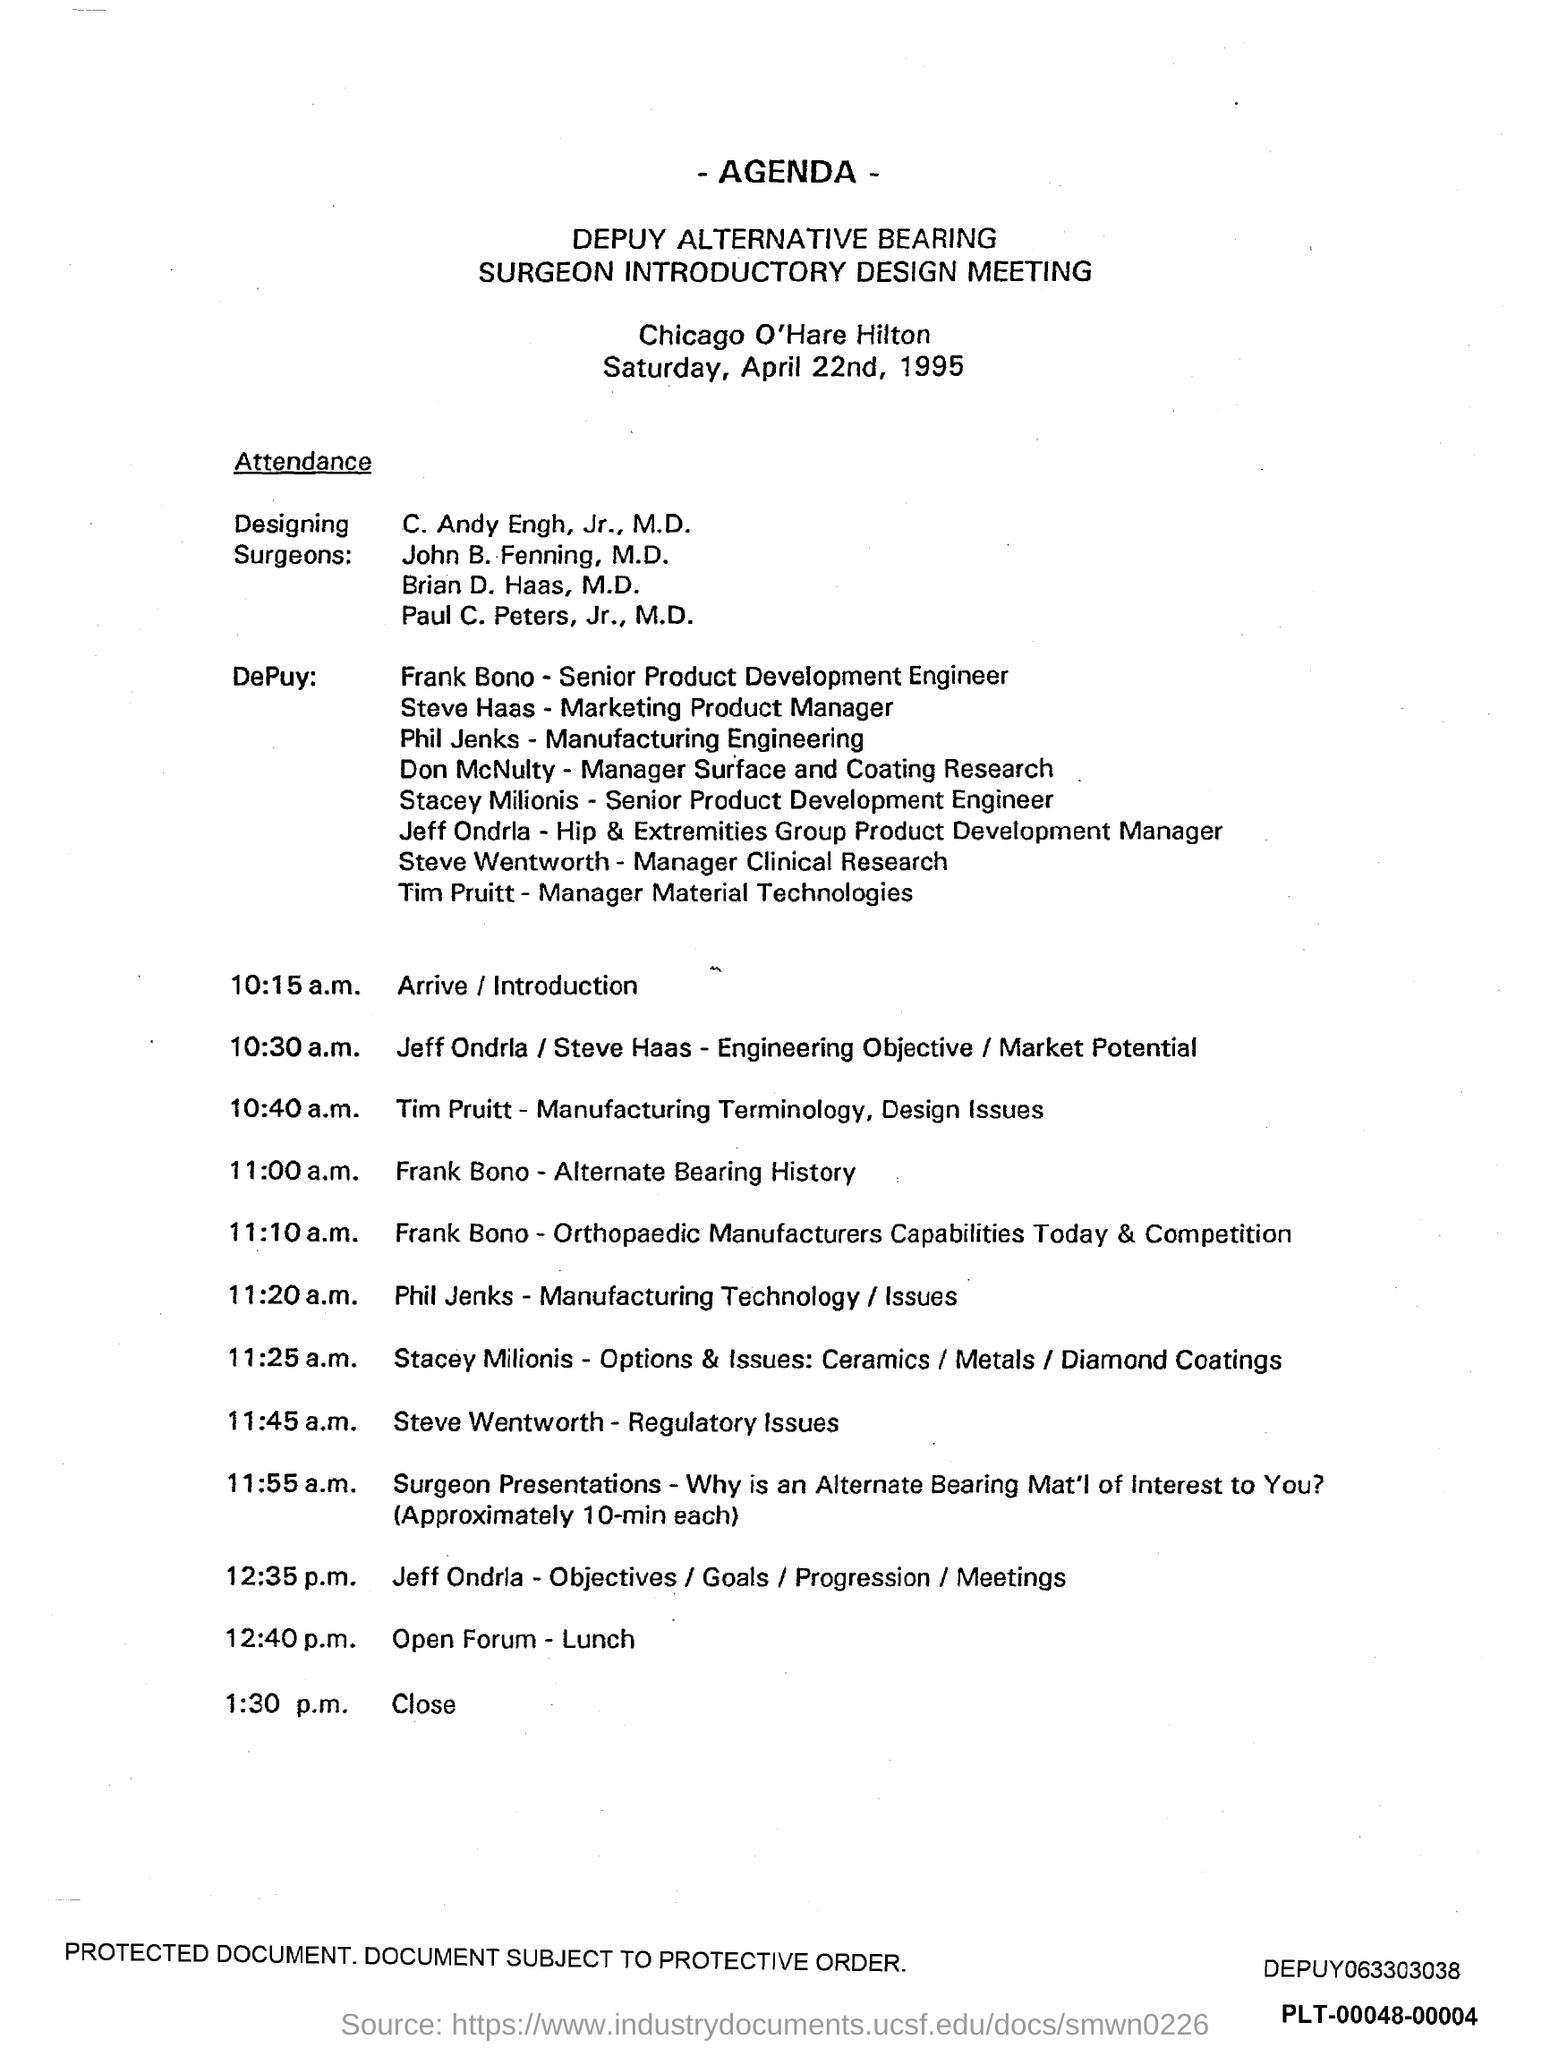Identify some key points in this picture. Steve Wentworth holds the position of Manager Clinical Research. The heading at the top of the page is 'Agenda'. Phil Jenks holds the position of Manufacturing Engineering in the company. The time scheduled for closure is 1:30 p.m. Steve Haas serves as the Marketing Product Manager. 